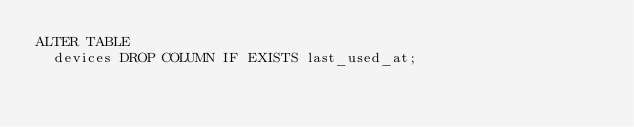Convert code to text. <code><loc_0><loc_0><loc_500><loc_500><_SQL_>ALTER TABLE
  devices DROP COLUMN IF EXISTS last_used_at;
</code> 